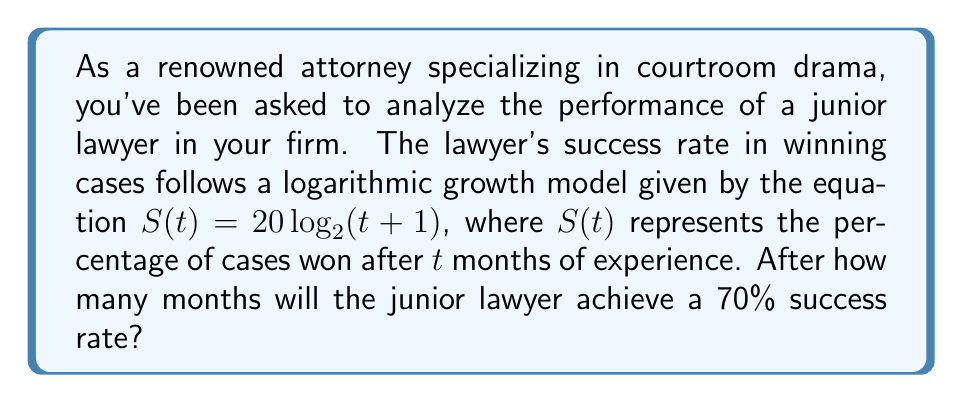Could you help me with this problem? Let's approach this step-by-step:

1) We're given the logarithmic growth model: $S(t) = 20 \log_2(t+1)$

2) We want to find $t$ when $S(t) = 70$. So, we set up the equation:

   $70 = 20 \log_2(t+1)$

3) Divide both sides by 20:

   $\frac{70}{20} = \log_2(t+1)$
   $3.5 = \log_2(t+1)$

4) To solve for $t$, we need to apply the inverse function (exponential) to both sides:

   $2^{3.5} = t+1$

5) Calculate $2^{3.5}$:

   $2^{3.5} \approx 11.3137$

6) Subtract 1 from both sides:

   $t \approx 11.3137 - 1 = 10.3137$

7) Since we're dealing with months, we need to round up to the nearest whole number:

   $t = 11$

Therefore, the junior lawyer will achieve a 70% success rate after 11 months.
Answer: 11 months 